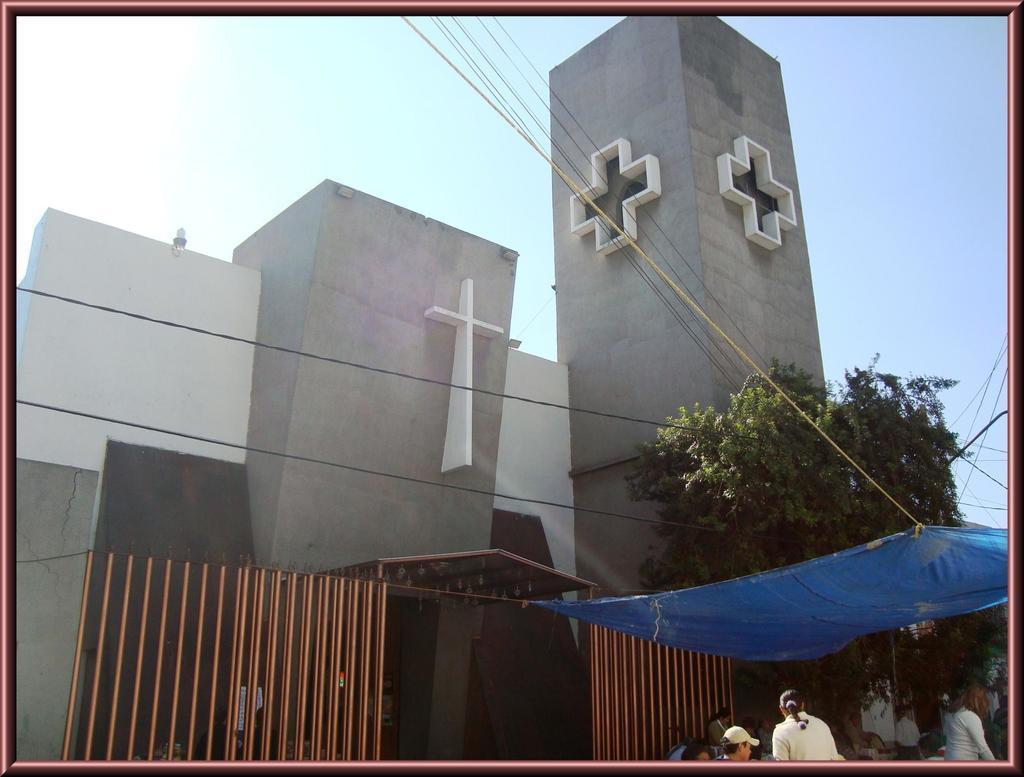Please provide a concise description of this image. To the right bottom of the image there are few people standing. Above them there is a blue cover. In the middle of the image there is a building with cross symbol on it. In front of the building there is a gate. And also there are wires and trees. And in the background there is a sky. 